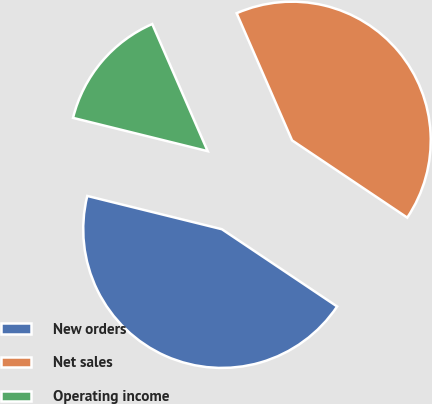Convert chart. <chart><loc_0><loc_0><loc_500><loc_500><pie_chart><fcel>New orders<fcel>Net sales<fcel>Operating income<nl><fcel>44.45%<fcel>40.94%<fcel>14.6%<nl></chart> 